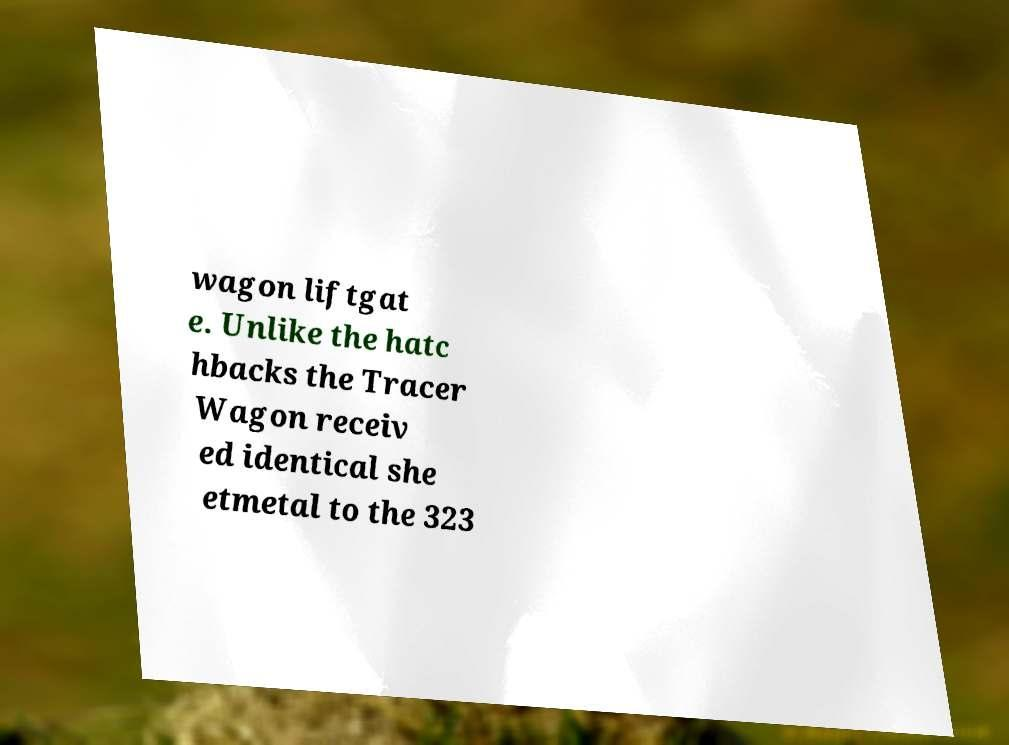Please identify and transcribe the text found in this image. wagon liftgat e. Unlike the hatc hbacks the Tracer Wagon receiv ed identical she etmetal to the 323 